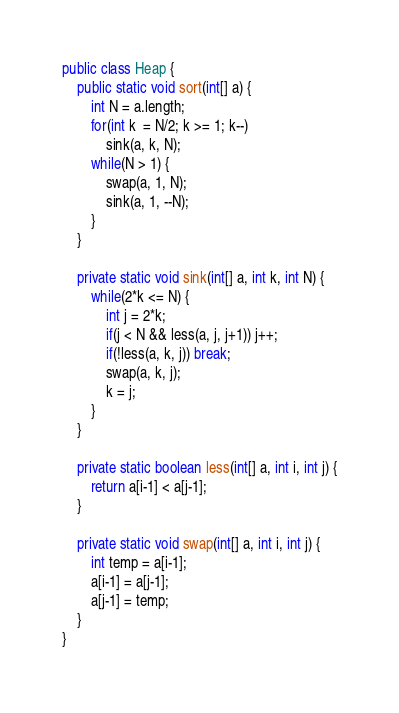Convert code to text. <code><loc_0><loc_0><loc_500><loc_500><_Java_>
public class Heap {
	public static void sort(int[] a) {
		int N = a.length;
		for(int k  = N/2; k >= 1; k--)
			sink(a, k, N);
		while(N > 1) {
			swap(a, 1, N);
			sink(a, 1, --N);
		}
	}

	private static void sink(int[] a, int k, int N) {
		while(2*k <= N) {
			int j = 2*k;
			if(j < N && less(a, j, j+1)) j++;
			if(!less(a, k, j)) break;
			swap(a, k, j);
			k = j;
		}
	}

	private static boolean less(int[] a, int i, int j) {
		return a[i-1] < a[j-1];
	}

	private static void swap(int[] a, int i, int j) {
		int temp = a[i-1];
		a[i-1] = a[j-1];
		a[j-1] = temp;
	}
}
</code> 